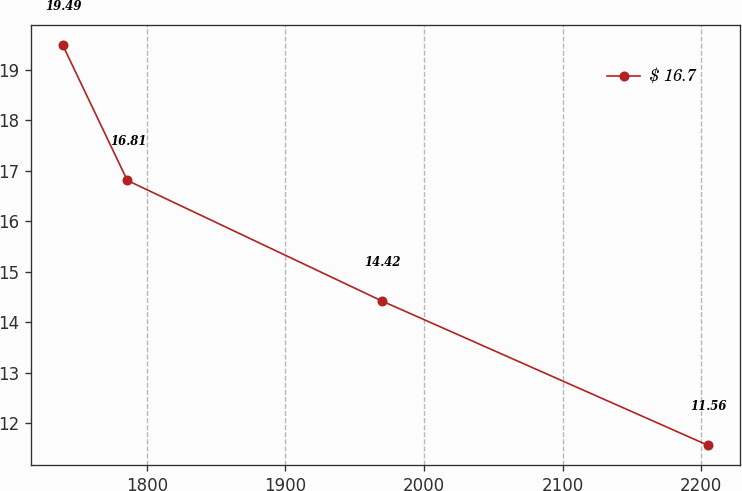Convert chart. <chart><loc_0><loc_0><loc_500><loc_500><line_chart><ecel><fcel>$ 16.7<nl><fcel>1739.42<fcel>19.49<nl><fcel>1785.95<fcel>16.81<nl><fcel>1969.58<fcel>14.42<nl><fcel>2204.69<fcel>11.56<nl></chart> 